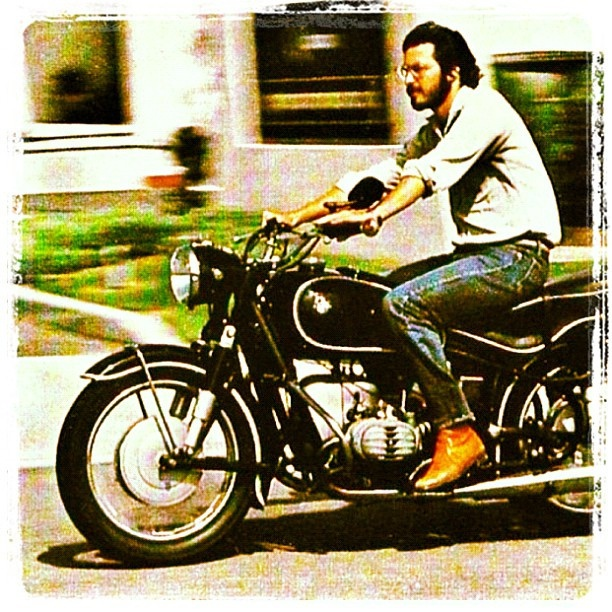Describe the objects in this image and their specific colors. I can see motorcycle in white, black, ivory, olive, and tan tones and people in white, ivory, black, olive, and khaki tones in this image. 